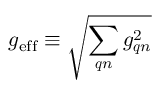Convert formula to latex. <formula><loc_0><loc_0><loc_500><loc_500>g _ { e f f } \equiv \sqrt { \sum _ { q n } g _ { q n } ^ { 2 } }</formula> 